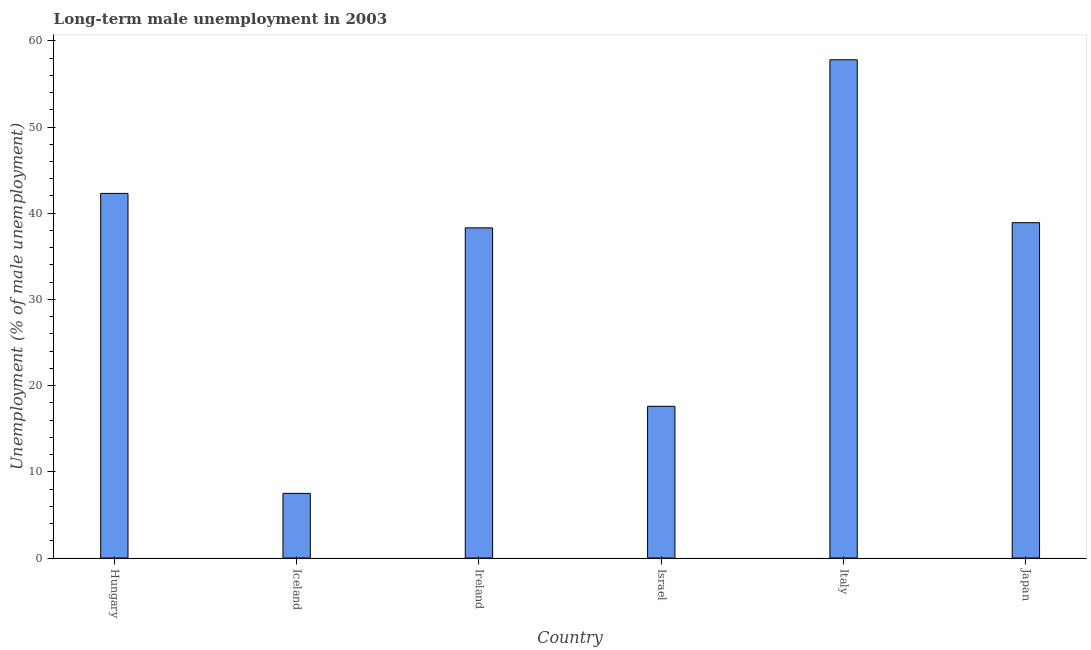Does the graph contain any zero values?
Provide a short and direct response. No. What is the title of the graph?
Make the answer very short. Long-term male unemployment in 2003. What is the label or title of the Y-axis?
Provide a succinct answer. Unemployment (% of male unemployment). What is the long-term male unemployment in Italy?
Your answer should be very brief. 57.8. Across all countries, what is the maximum long-term male unemployment?
Your response must be concise. 57.8. What is the sum of the long-term male unemployment?
Make the answer very short. 202.4. What is the average long-term male unemployment per country?
Provide a succinct answer. 33.73. What is the median long-term male unemployment?
Offer a very short reply. 38.6. In how many countries, is the long-term male unemployment greater than 48 %?
Ensure brevity in your answer.  1. What is the ratio of the long-term male unemployment in Hungary to that in Italy?
Ensure brevity in your answer.  0.73. Is the long-term male unemployment in Italy less than that in Japan?
Keep it short and to the point. No. Is the difference between the long-term male unemployment in Ireland and Israel greater than the difference between any two countries?
Your response must be concise. No. What is the difference between the highest and the lowest long-term male unemployment?
Your answer should be very brief. 50.3. What is the difference between two consecutive major ticks on the Y-axis?
Your answer should be very brief. 10. Are the values on the major ticks of Y-axis written in scientific E-notation?
Offer a terse response. No. What is the Unemployment (% of male unemployment) in Hungary?
Your answer should be very brief. 42.3. What is the Unemployment (% of male unemployment) in Ireland?
Ensure brevity in your answer.  38.3. What is the Unemployment (% of male unemployment) of Israel?
Ensure brevity in your answer.  17.6. What is the Unemployment (% of male unemployment) of Italy?
Your answer should be compact. 57.8. What is the Unemployment (% of male unemployment) in Japan?
Your answer should be compact. 38.9. What is the difference between the Unemployment (% of male unemployment) in Hungary and Iceland?
Ensure brevity in your answer.  34.8. What is the difference between the Unemployment (% of male unemployment) in Hungary and Ireland?
Offer a very short reply. 4. What is the difference between the Unemployment (% of male unemployment) in Hungary and Israel?
Ensure brevity in your answer.  24.7. What is the difference between the Unemployment (% of male unemployment) in Hungary and Italy?
Give a very brief answer. -15.5. What is the difference between the Unemployment (% of male unemployment) in Iceland and Ireland?
Offer a very short reply. -30.8. What is the difference between the Unemployment (% of male unemployment) in Iceland and Israel?
Offer a terse response. -10.1. What is the difference between the Unemployment (% of male unemployment) in Iceland and Italy?
Your answer should be compact. -50.3. What is the difference between the Unemployment (% of male unemployment) in Iceland and Japan?
Keep it short and to the point. -31.4. What is the difference between the Unemployment (% of male unemployment) in Ireland and Israel?
Offer a very short reply. 20.7. What is the difference between the Unemployment (% of male unemployment) in Ireland and Italy?
Your response must be concise. -19.5. What is the difference between the Unemployment (% of male unemployment) in Ireland and Japan?
Offer a very short reply. -0.6. What is the difference between the Unemployment (% of male unemployment) in Israel and Italy?
Make the answer very short. -40.2. What is the difference between the Unemployment (% of male unemployment) in Israel and Japan?
Offer a terse response. -21.3. What is the difference between the Unemployment (% of male unemployment) in Italy and Japan?
Keep it short and to the point. 18.9. What is the ratio of the Unemployment (% of male unemployment) in Hungary to that in Iceland?
Ensure brevity in your answer.  5.64. What is the ratio of the Unemployment (% of male unemployment) in Hungary to that in Ireland?
Your answer should be very brief. 1.1. What is the ratio of the Unemployment (% of male unemployment) in Hungary to that in Israel?
Keep it short and to the point. 2.4. What is the ratio of the Unemployment (% of male unemployment) in Hungary to that in Italy?
Your response must be concise. 0.73. What is the ratio of the Unemployment (% of male unemployment) in Hungary to that in Japan?
Your response must be concise. 1.09. What is the ratio of the Unemployment (% of male unemployment) in Iceland to that in Ireland?
Your answer should be very brief. 0.2. What is the ratio of the Unemployment (% of male unemployment) in Iceland to that in Israel?
Keep it short and to the point. 0.43. What is the ratio of the Unemployment (% of male unemployment) in Iceland to that in Italy?
Your answer should be compact. 0.13. What is the ratio of the Unemployment (% of male unemployment) in Iceland to that in Japan?
Make the answer very short. 0.19. What is the ratio of the Unemployment (% of male unemployment) in Ireland to that in Israel?
Offer a terse response. 2.18. What is the ratio of the Unemployment (% of male unemployment) in Ireland to that in Italy?
Your answer should be very brief. 0.66. What is the ratio of the Unemployment (% of male unemployment) in Israel to that in Italy?
Your answer should be very brief. 0.3. What is the ratio of the Unemployment (% of male unemployment) in Israel to that in Japan?
Ensure brevity in your answer.  0.45. What is the ratio of the Unemployment (% of male unemployment) in Italy to that in Japan?
Provide a short and direct response. 1.49. 